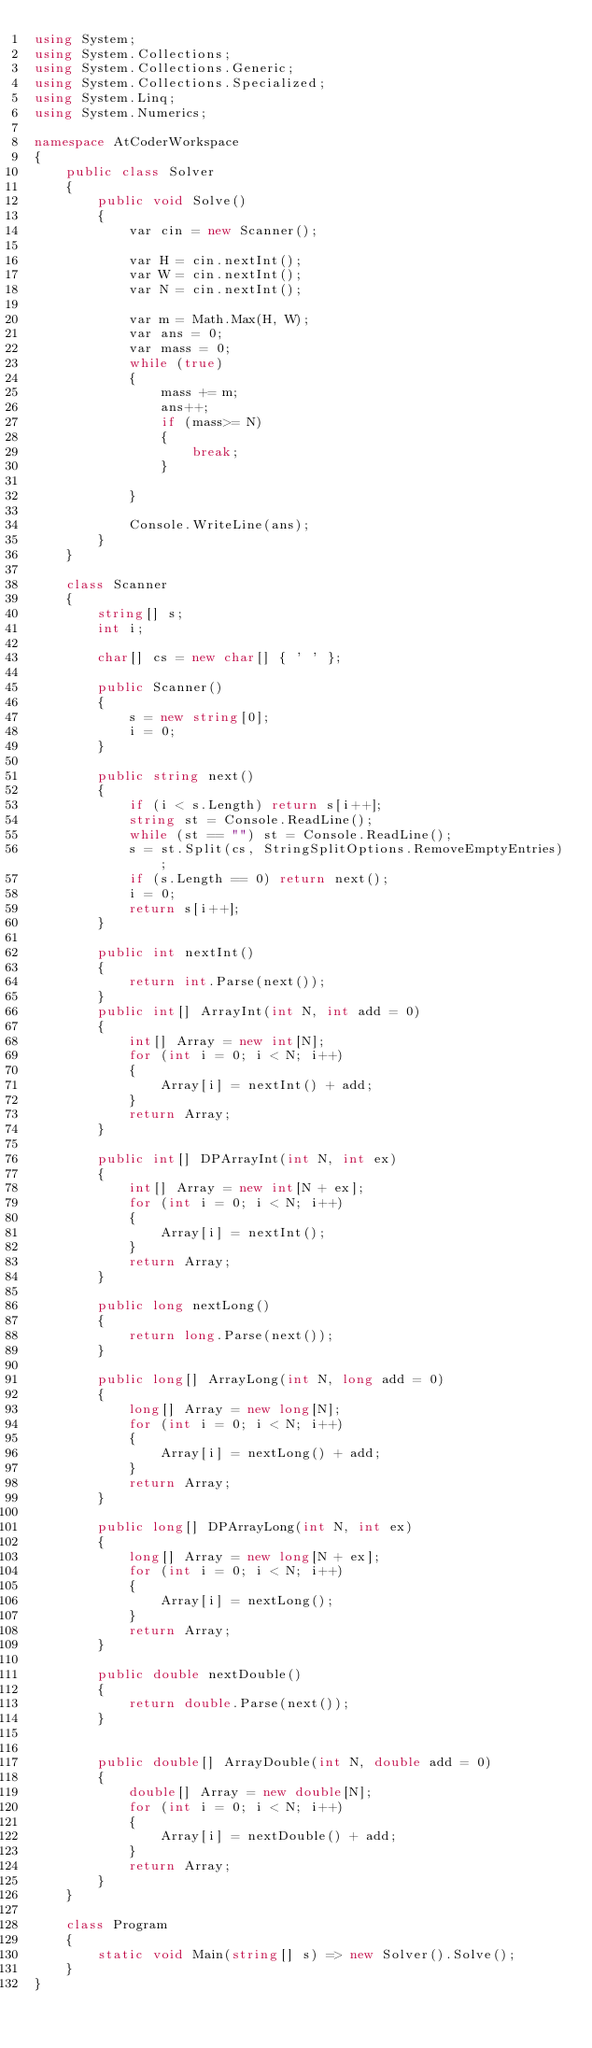Convert code to text. <code><loc_0><loc_0><loc_500><loc_500><_C#_>using System;
using System.Collections;
using System.Collections.Generic;
using System.Collections.Specialized;
using System.Linq;
using System.Numerics;

namespace AtCoderWorkspace
{
    public class Solver
    {
        public void Solve()
        {
            var cin = new Scanner();
            
            var H = cin.nextInt();
            var W = cin.nextInt();
            var N = cin.nextInt();

            var m = Math.Max(H, W);
            var ans = 0;
            var mass = 0;
            while (true)
            {
                mass += m;
                ans++;
                if (mass>= N)
                {
                    break;
                }
                
            }

            Console.WriteLine(ans);
        }
    }

    class Scanner
    {
        string[] s;
        int i;

        char[] cs = new char[] { ' ' };

        public Scanner()
        {
            s = new string[0];
            i = 0;
        }

        public string next()
        {
            if (i < s.Length) return s[i++];
            string st = Console.ReadLine();
            while (st == "") st = Console.ReadLine();
            s = st.Split(cs, StringSplitOptions.RemoveEmptyEntries);
            if (s.Length == 0) return next();
            i = 0;
            return s[i++];
        }

        public int nextInt()
        {
            return int.Parse(next());
        }
        public int[] ArrayInt(int N, int add = 0)
        {
            int[] Array = new int[N];
            for (int i = 0; i < N; i++)
            {
                Array[i] = nextInt() + add;
            }
            return Array;
        }

        public int[] DPArrayInt(int N, int ex)
        {
            int[] Array = new int[N + ex];
            for (int i = 0; i < N; i++)
            {
                Array[i] = nextInt();
            }
            return Array;
        }

        public long nextLong()
        {
            return long.Parse(next());
        }

        public long[] ArrayLong(int N, long add = 0)
        {
            long[] Array = new long[N];
            for (int i = 0; i < N; i++)
            {
                Array[i] = nextLong() + add;
            }
            return Array;
        }

        public long[] DPArrayLong(int N, int ex)
        {
            long[] Array = new long[N + ex];
            for (int i = 0; i < N; i++)
            {
                Array[i] = nextLong();
            }
            return Array;
        }

        public double nextDouble()
        {
            return double.Parse(next());
        }


        public double[] ArrayDouble(int N, double add = 0)
        {
            double[] Array = new double[N];
            for (int i = 0; i < N; i++)
            {
                Array[i] = nextDouble() + add;
            }
            return Array;
        }
    }

    class Program
    {
        static void Main(string[] s) => new Solver().Solve();
    }
}
</code> 